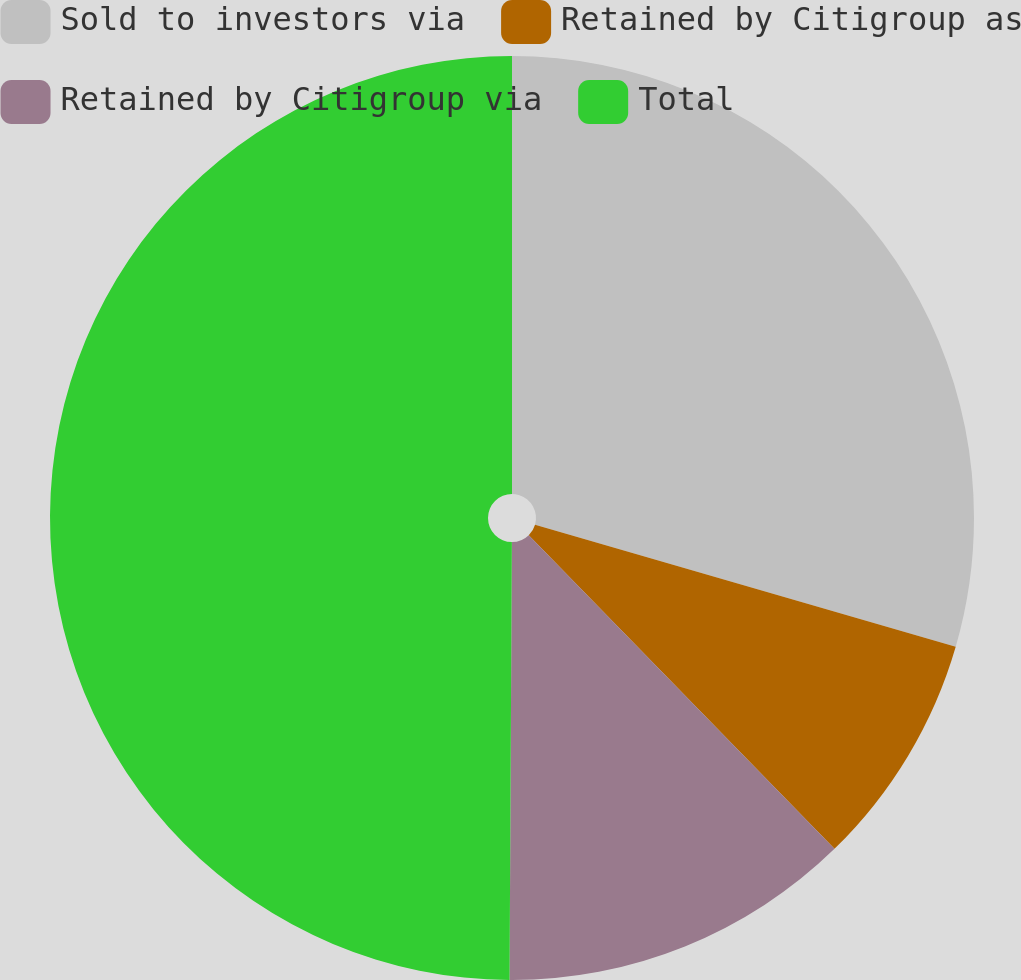<chart> <loc_0><loc_0><loc_500><loc_500><pie_chart><fcel>Sold to investors via<fcel>Retained by Citigroup as<fcel>Retained by Citigroup via<fcel>Total<nl><fcel>29.49%<fcel>8.21%<fcel>12.38%<fcel>49.91%<nl></chart> 